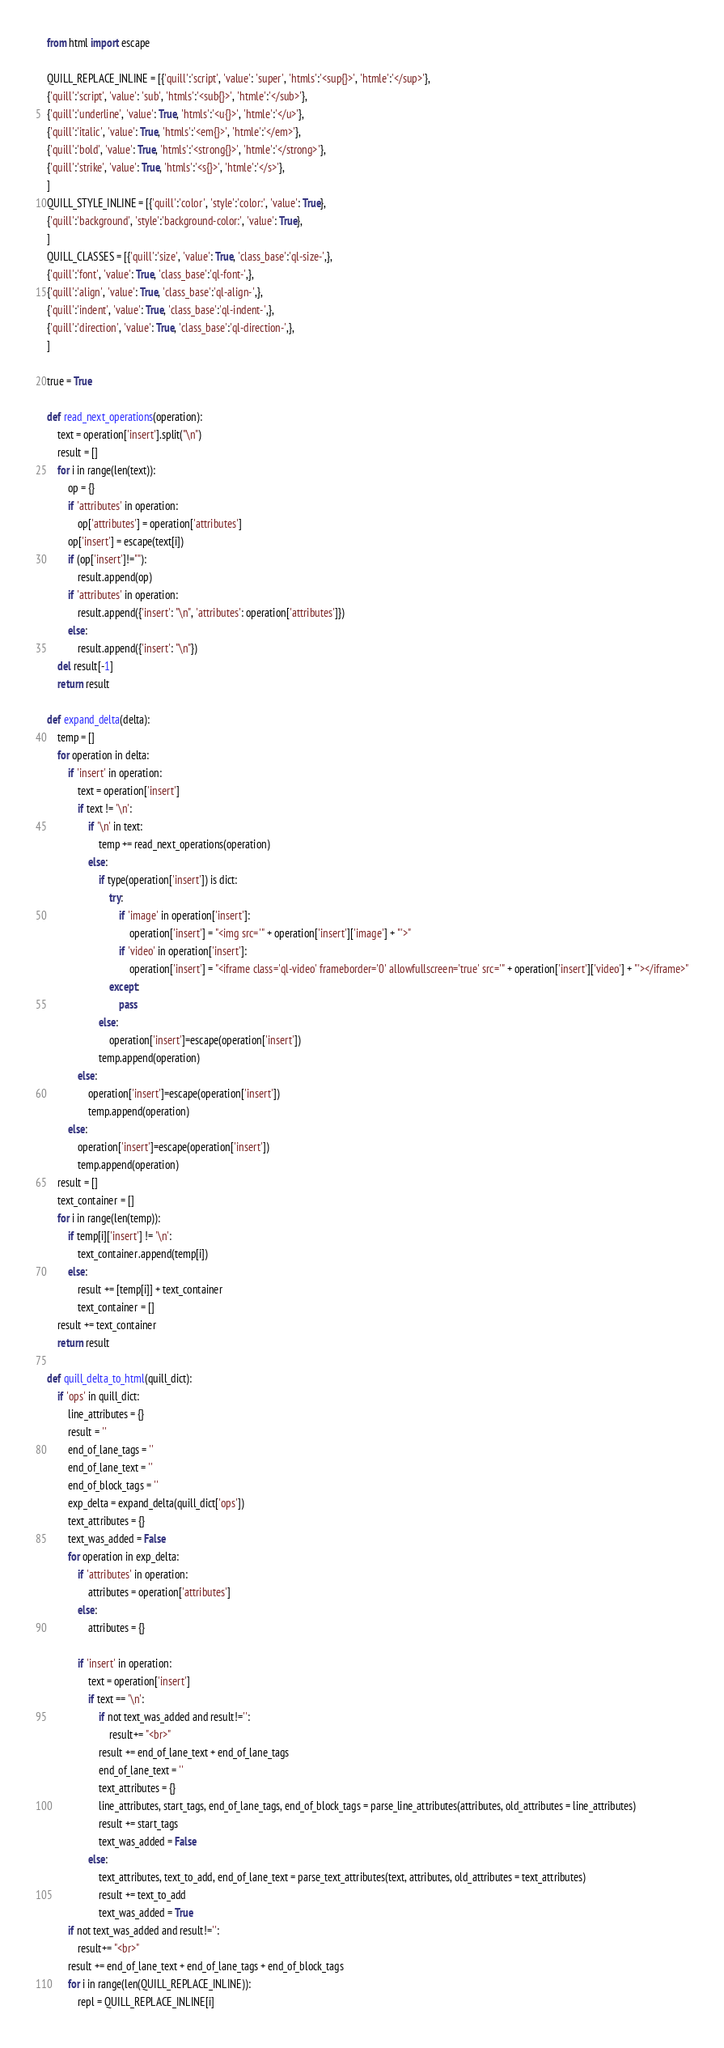Convert code to text. <code><loc_0><loc_0><loc_500><loc_500><_Python_>from html import escape

QUILL_REPLACE_INLINE = [{'quill':'script', 'value': 'super', 'htmls':'<sup{}>', 'htmle':'</sup>'},
{'quill':'script', 'value': 'sub', 'htmls':'<sub{}>', 'htmle':'</sub>'},
{'quill':'underline', 'value': True, 'htmls':'<u{}>', 'htmle':'</u>'},
{'quill':'italic', 'value': True, 'htmls':'<em{}>', 'htmle':'</em>'},
{'quill':'bold', 'value': True, 'htmls':'<strong{}>', 'htmle':'</strong>'},
{'quill':'strike', 'value': True, 'htmls':'<s{}>', 'htmle':'</s>'},
]
QUILL_STYLE_INLINE = [{'quill':'color', 'style':'color:', 'value': True},
{'quill':'background', 'style':'background-color:', 'value': True},
]
QUILL_CLASSES = [{'quill':'size', 'value': True, 'class_base':'ql-size-',},
{'quill':'font', 'value': True, 'class_base':'ql-font-',},
{'quill':'align', 'value': True, 'class_base':'ql-align-',},
{'quill':'indent', 'value': True, 'class_base':'ql-indent-',},
{'quill':'direction', 'value': True, 'class_base':'ql-direction-',},
]

true = True

def read_next_operations(operation):
    text = operation['insert'].split("\n")
    result = []
    for i in range(len(text)):
        op = {}
        if 'attributes' in operation:
            op['attributes'] = operation['attributes']
        op['insert'] = escape(text[i])
        if (op['insert']!=""):
            result.append(op)
        if 'attributes' in operation:
            result.append({'insert': "\n", 'attributes': operation['attributes']})
        else:
            result.append({'insert': "\n"})
    del result[-1]
    return result

def expand_delta(delta):
    temp = []
    for operation in delta:
        if 'insert' in operation:
            text = operation['insert']
            if text != '\n':
                if '\n' in text:
                    temp += read_next_operations(operation)
                else:
                    if type(operation['insert']) is dict:
                        try:
                            if 'image' in operation['insert']:
                                operation['insert'] = "<img src='" + operation['insert']['image'] + "'>"
                            if 'video' in operation['insert']:
                                operation['insert'] = "<iframe class='ql-video' frameborder='0' allowfullscreen='true' src='" + operation['insert']['video'] + "'></iframe>"
                        except:
                            pass
                    else:
                        operation['insert']=escape(operation['insert'])
                    temp.append(operation)
            else:
                operation['insert']=escape(operation['insert'])
                temp.append(operation)
        else:
            operation['insert']=escape(operation['insert'])
            temp.append(operation)
    result = []
    text_container = []
    for i in range(len(temp)):
        if temp[i]['insert'] != '\n':
            text_container.append(temp[i])
        else:
            result += [temp[i]] + text_container
            text_container = []
    result += text_container
    return result

def quill_delta_to_html(quill_dict):
    if 'ops' in quill_dict:
        line_attributes = {}
        result = ''
        end_of_lane_tags = ''
        end_of_lane_text = ''
        end_of_block_tags = ''
        exp_delta = expand_delta(quill_dict['ops'])
        text_attributes = {}
        text_was_added = False
        for operation in exp_delta:
            if 'attributes' in operation:
                attributes = operation['attributes']
            else:
                attributes = {}

            if 'insert' in operation:
                text = operation['insert']
                if text == '\n':
                    if not text_was_added and result!='':
                        result+= "<br>"
                    result += end_of_lane_text + end_of_lane_tags
                    end_of_lane_text = ''
                    text_attributes = {}
                    line_attributes, start_tags, end_of_lane_tags, end_of_block_tags = parse_line_attributes(attributes, old_attributes = line_attributes)
                    result += start_tags
                    text_was_added = False
                else:
                    text_attributes, text_to_add, end_of_lane_text = parse_text_attributes(text, attributes, old_attributes = text_attributes)
                    result += text_to_add
                    text_was_added = True
        if not text_was_added and result!='':
            result+= "<br>"
        result += end_of_lane_text + end_of_lane_tags + end_of_block_tags
        for i in range(len(QUILL_REPLACE_INLINE)):
            repl = QUILL_REPLACE_INLINE[i]</code> 